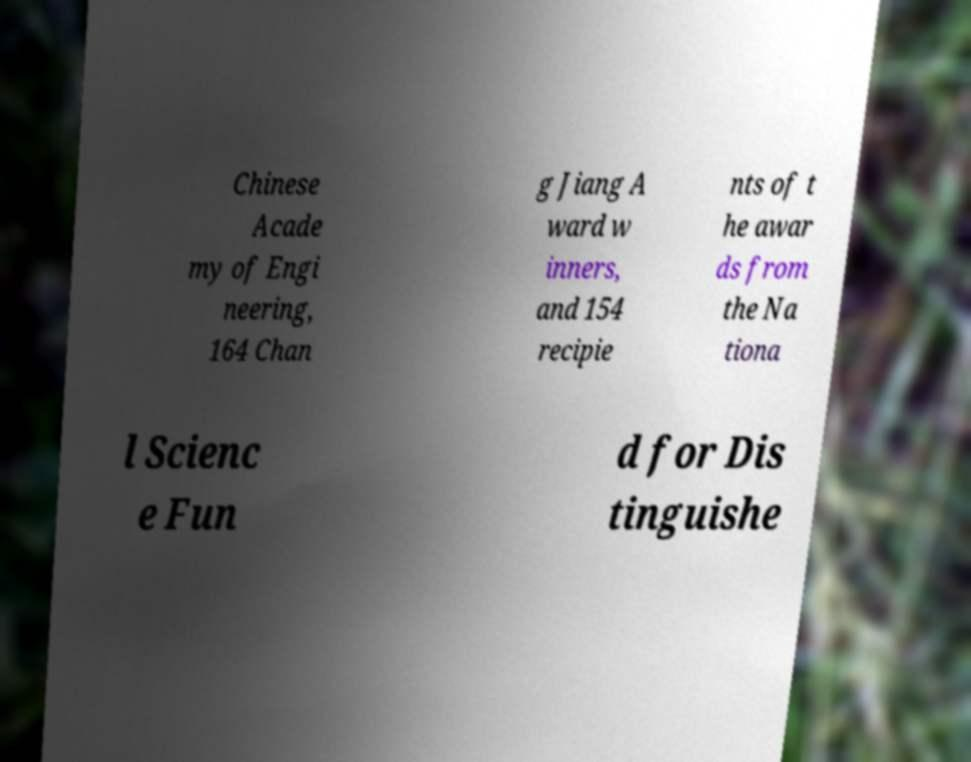There's text embedded in this image that I need extracted. Can you transcribe it verbatim? Chinese Acade my of Engi neering, 164 Chan g Jiang A ward w inners, and 154 recipie nts of t he awar ds from the Na tiona l Scienc e Fun d for Dis tinguishe 